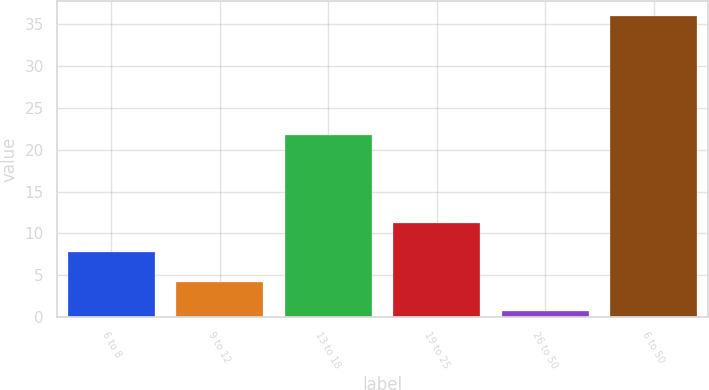Convert chart to OTSL. <chart><loc_0><loc_0><loc_500><loc_500><bar_chart><fcel>6 to 8<fcel>9 to 12<fcel>13 to 18<fcel>19 to 25<fcel>26 to 50<fcel>6 to 50<nl><fcel>7.76<fcel>4.23<fcel>21.8<fcel>11.29<fcel>0.7<fcel>36<nl></chart> 